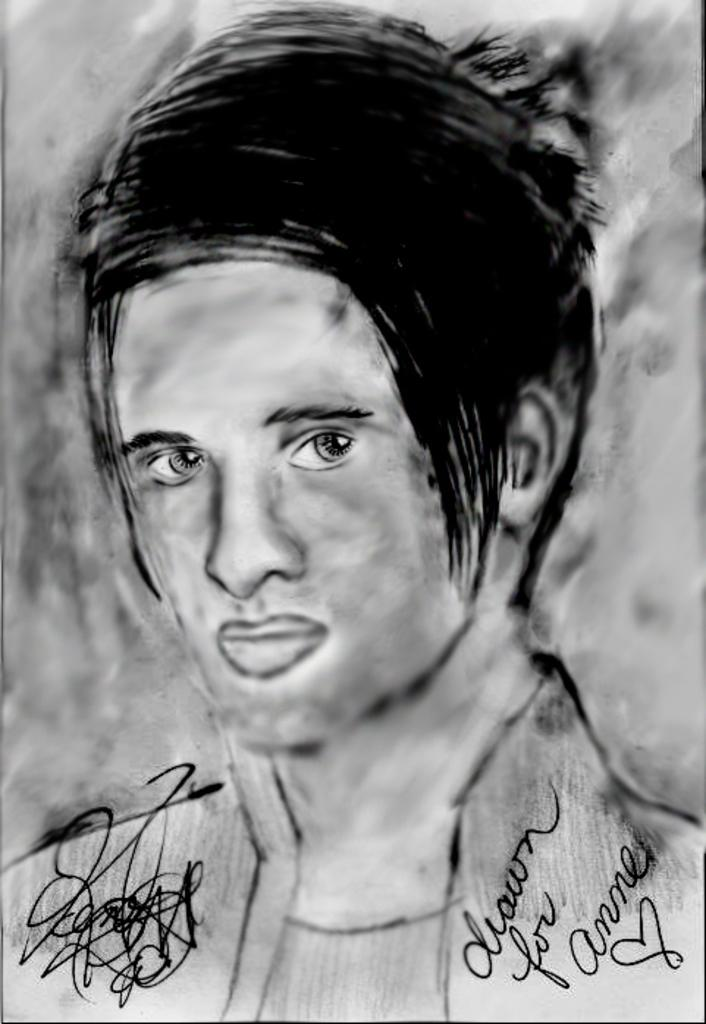What is depicted in the image? There is a drawing of a man in the image. What else can be found in the image besides the drawing of the man? There is text in the image. What type of pain is the man experiencing in the image? There is no indication of pain in the image, as it only features a drawing of a man and text. 